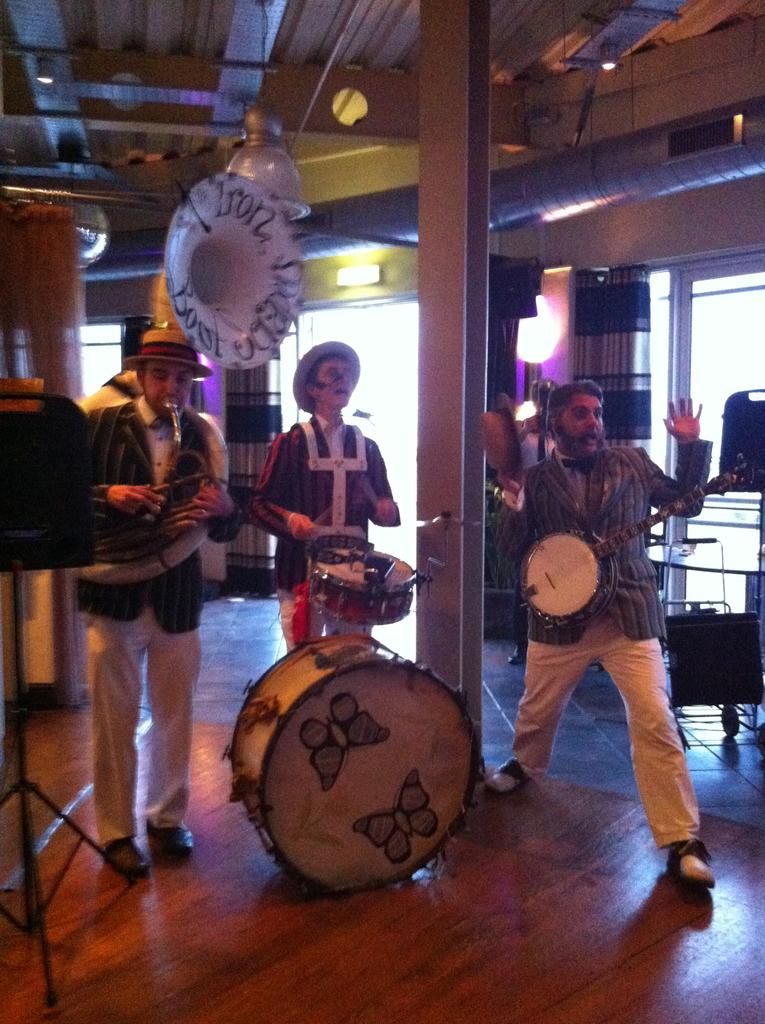How many people are in the image? There are three men in the image. What are the men doing in the image? The men are standing and playing musical instruments. How much money is being exchanged between the men in the image? There is no indication of money or any financial transaction in the image. What fictional character might be present in the image? There is no fictional character present in the image; it features three men playing musical instruments. 